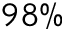Convert formula to latex. <formula><loc_0><loc_0><loc_500><loc_500>9 8 \%</formula> 